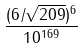<formula> <loc_0><loc_0><loc_500><loc_500>\frac { ( 6 / \sqrt { 2 0 9 } ) ^ { 6 } } { 1 0 ^ { 1 6 9 } }</formula> 